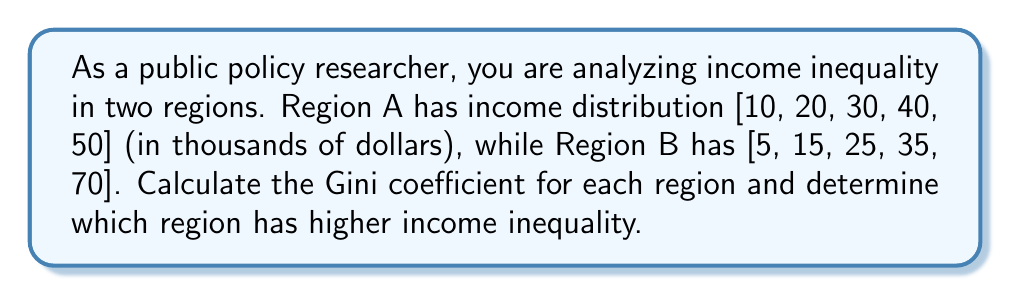What is the answer to this math problem? To calculate the Gini coefficient, we'll follow these steps for each region:

1. Calculate the mean income
2. Calculate the absolute differences between each pair of incomes
3. Sum these differences
4. Apply the Gini coefficient formula

For Region A:

1. Mean income: $\mu_A = \frac{10 + 20 + 30 + 40 + 50}{5} = 30$

2. Absolute differences:
   $|10-20| + |10-30| + |10-40| + |10-50| = 10 + 20 + 30 + 40 = 100$
   $|20-30| + |20-40| + |20-50| = 10 + 20 + 30 = 60$
   $|30-40| + |30-50| = 10 + 20 = 30$
   $|40-50| = 10$

3. Sum of differences: $100 + 60 + 30 + 10 = 200$

4. Gini coefficient:
   $$G_A = \frac{200}{2 \cdot 5^2 \cdot 30} = \frac{200}{750} = 0.2667$$

For Region B:

1. Mean income: $\mu_B = \frac{5 + 15 + 25 + 35 + 70}{5} = 30$

2. Absolute differences:
   $|5-15| + |5-25| + |5-35| + |5-70| = 10 + 20 + 30 + 65 = 125$
   $|15-25| + |15-35| + |15-70| = 10 + 20 + 55 = 85$
   $|25-35| + |25-70| = 10 + 45 = 55$
   $|35-70| = 35$

3. Sum of differences: $125 + 85 + 55 + 35 = 300$

4. Gini coefficient:
   $$G_B = \frac{300}{2 \cdot 5^2 \cdot 30} = \frac{300}{750} = 0.4$$

Region B has a higher Gini coefficient (0.4 > 0.2667), indicating greater income inequality.
Answer: Region A: 0.2667, Region B: 0.4. Region B has higher income inequality. 